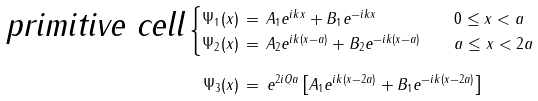Convert formula to latex. <formula><loc_0><loc_0><loc_500><loc_500>\text {\sl primitive cell} \, & \begin{cases} \Psi _ { 1 } ( x ) \, = \, A _ { 1 } e ^ { i k x } + B _ { 1 } e ^ { - i k x } \quad & 0 \leq x < a \\ \Psi _ { 2 } ( x ) \, = \, A _ { 2 } e ^ { i k ( x - a ) } + B _ { 2 } e ^ { - i k ( x - a ) } \quad & a \leq x < 2 a \end{cases} \\ & \quad \Psi _ { 3 } ( x ) \, = \, e ^ { 2 i Q a } \left [ A _ { 1 } e ^ { i k ( x - 2 a ) } + B _ { 1 } e ^ { - i k ( x - 2 a ) } \right ]</formula> 